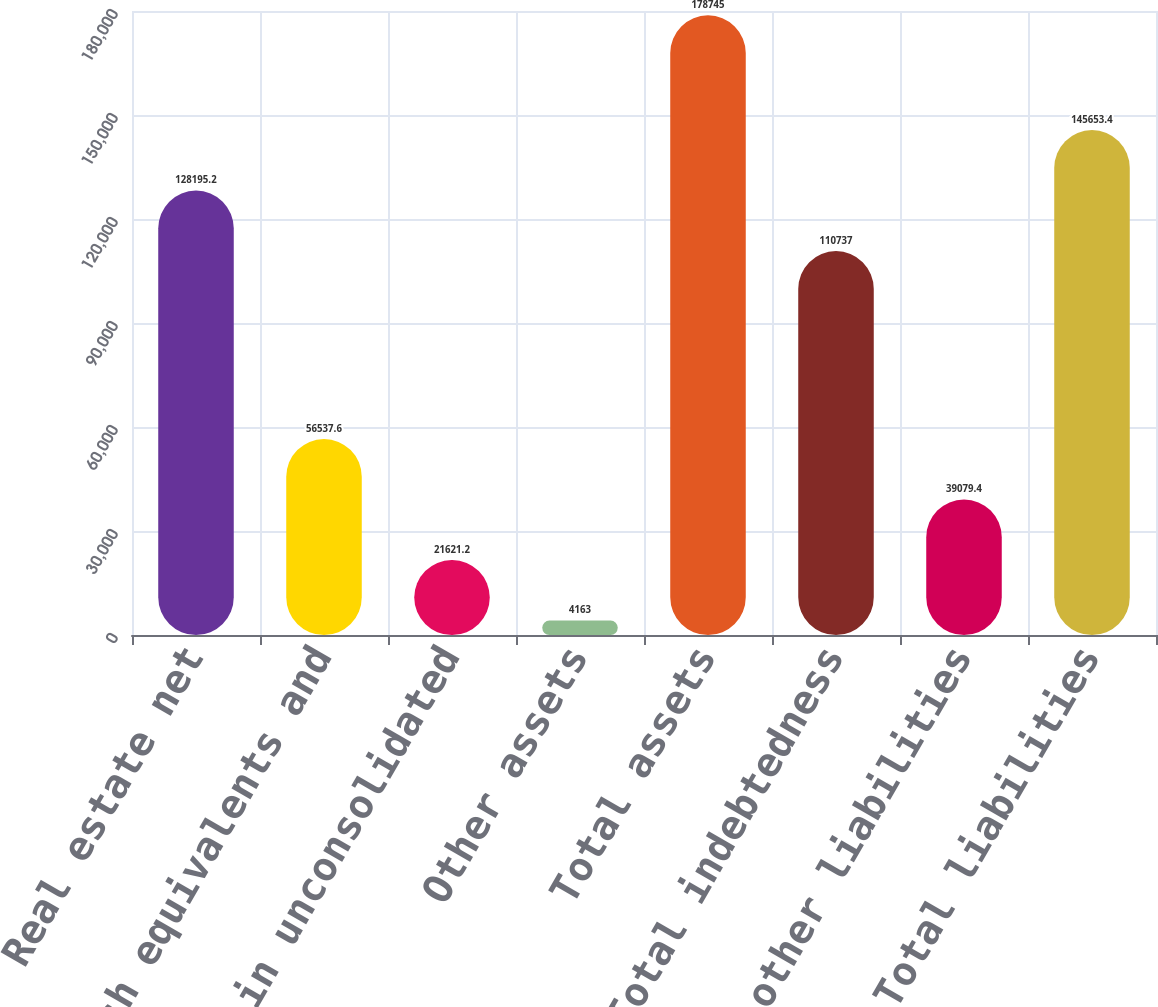Convert chart to OTSL. <chart><loc_0><loc_0><loc_500><loc_500><bar_chart><fcel>Real estate net<fcel>Cash and cash equivalents and<fcel>Investment in unconsolidated<fcel>Other assets<fcel>Total assets<fcel>Total indebtedness<fcel>Accrued and other liabilities<fcel>Total liabilities<nl><fcel>128195<fcel>56537.6<fcel>21621.2<fcel>4163<fcel>178745<fcel>110737<fcel>39079.4<fcel>145653<nl></chart> 